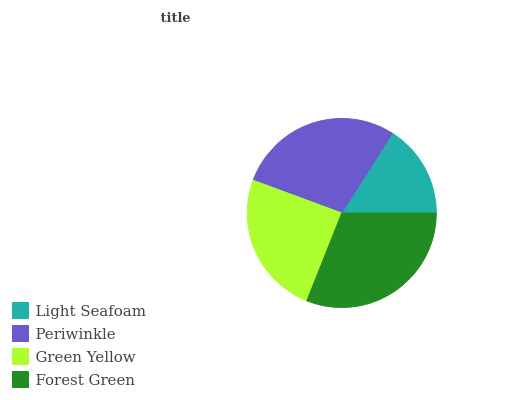Is Light Seafoam the minimum?
Answer yes or no. Yes. Is Forest Green the maximum?
Answer yes or no. Yes. Is Periwinkle the minimum?
Answer yes or no. No. Is Periwinkle the maximum?
Answer yes or no. No. Is Periwinkle greater than Light Seafoam?
Answer yes or no. Yes. Is Light Seafoam less than Periwinkle?
Answer yes or no. Yes. Is Light Seafoam greater than Periwinkle?
Answer yes or no. No. Is Periwinkle less than Light Seafoam?
Answer yes or no. No. Is Periwinkle the high median?
Answer yes or no. Yes. Is Green Yellow the low median?
Answer yes or no. Yes. Is Green Yellow the high median?
Answer yes or no. No. Is Periwinkle the low median?
Answer yes or no. No. 